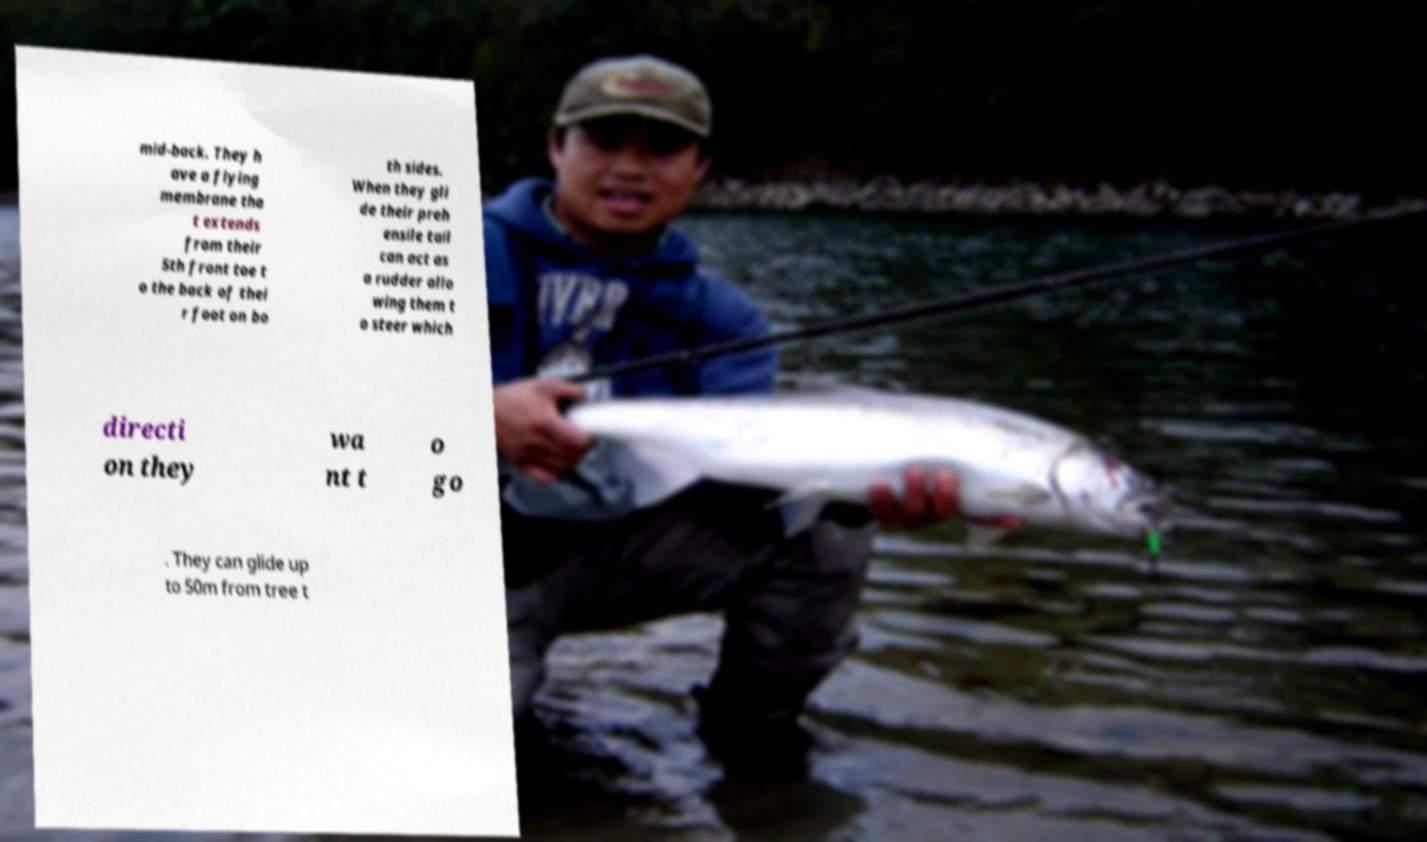Can you read and provide the text displayed in the image?This photo seems to have some interesting text. Can you extract and type it out for me? mid-back. They h ave a flying membrane tha t extends from their 5th front toe t o the back of thei r foot on bo th sides. When they gli de their preh ensile tail can act as a rudder allo wing them t o steer which directi on they wa nt t o go . They can glide up to 50m from tree t 